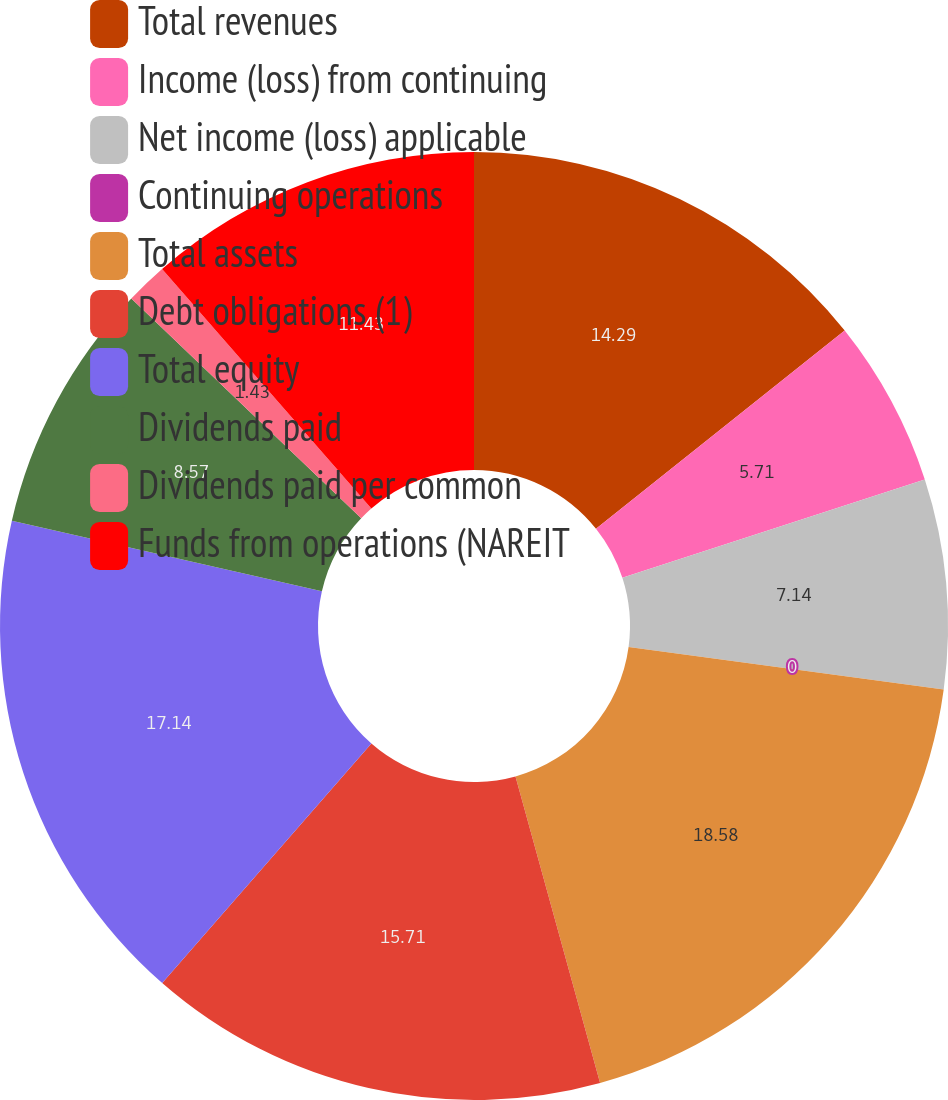Convert chart. <chart><loc_0><loc_0><loc_500><loc_500><pie_chart><fcel>Total revenues<fcel>Income (loss) from continuing<fcel>Net income (loss) applicable<fcel>Continuing operations<fcel>Total assets<fcel>Debt obligations (1)<fcel>Total equity<fcel>Dividends paid<fcel>Dividends paid per common<fcel>Funds from operations (NAREIT<nl><fcel>14.29%<fcel>5.71%<fcel>7.14%<fcel>0.0%<fcel>18.57%<fcel>15.71%<fcel>17.14%<fcel>8.57%<fcel>1.43%<fcel>11.43%<nl></chart> 